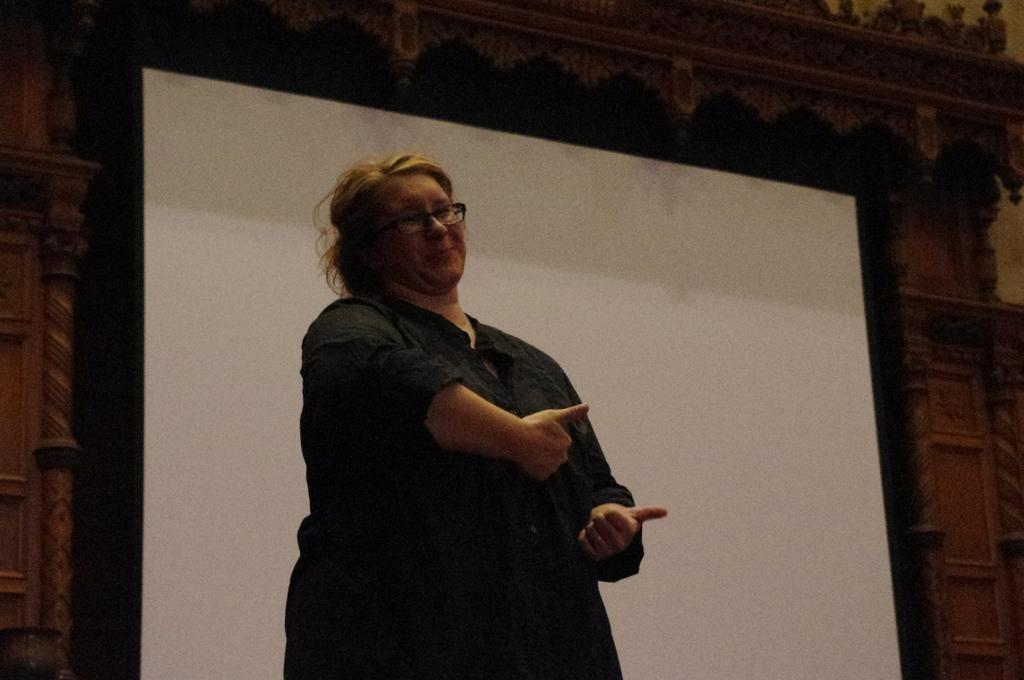Could you give a brief overview of what you see in this image? In this picture there is a woman wearing black dress is standing and there is a projector behind her and there is a designed wall in the background. 